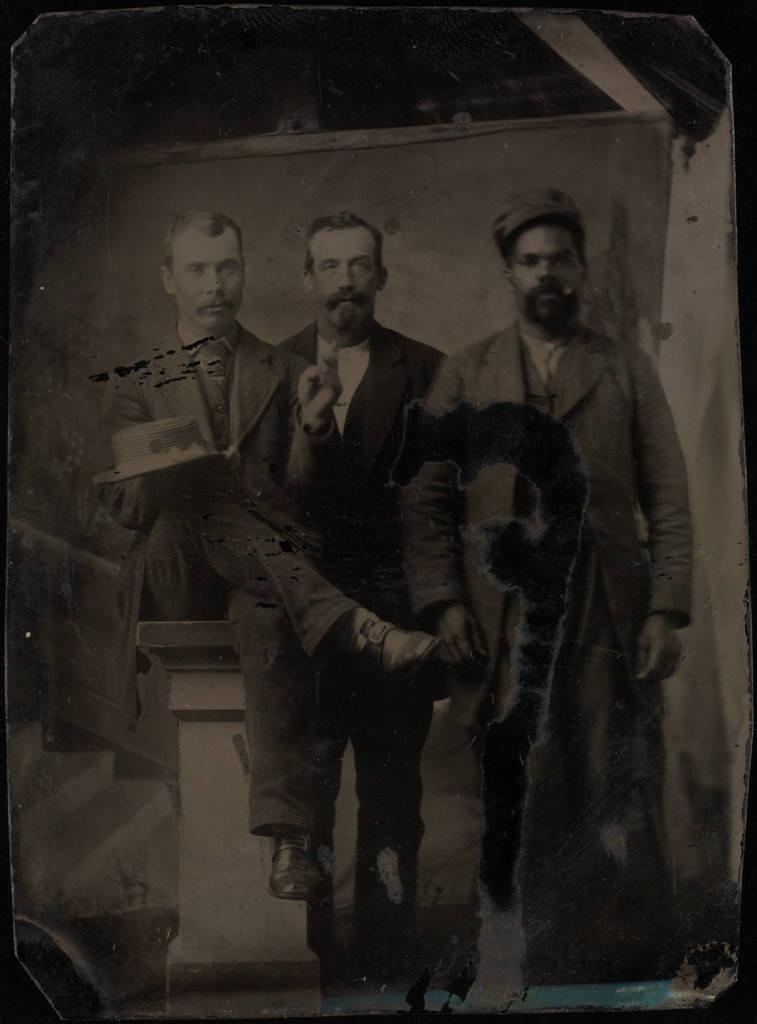How would you summarize this image in a sentence or two? In this image I see a picture which is of black and white color and I see 3 men in which this man is sitting and I see that all of them are wearing suits. 